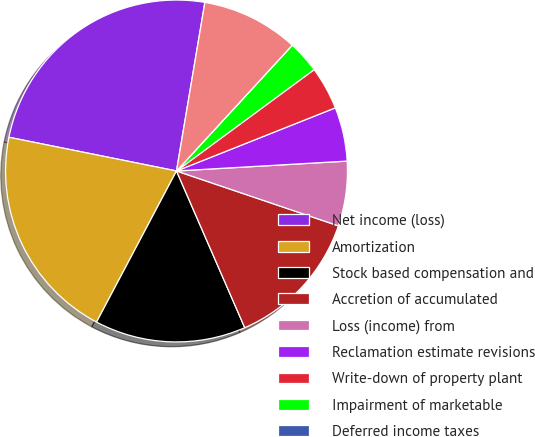<chart> <loc_0><loc_0><loc_500><loc_500><pie_chart><fcel>Net income (loss)<fcel>Amortization<fcel>Stock based compensation and<fcel>Accretion of accumulated<fcel>Loss (income) from<fcel>Reclamation estimate revisions<fcel>Write-down of property plant<fcel>Impairment of marketable<fcel>Deferred income taxes<fcel>Gain on asset sales net<nl><fcel>24.49%<fcel>20.41%<fcel>14.28%<fcel>13.26%<fcel>6.12%<fcel>5.1%<fcel>4.08%<fcel>3.06%<fcel>0.0%<fcel>9.18%<nl></chart> 